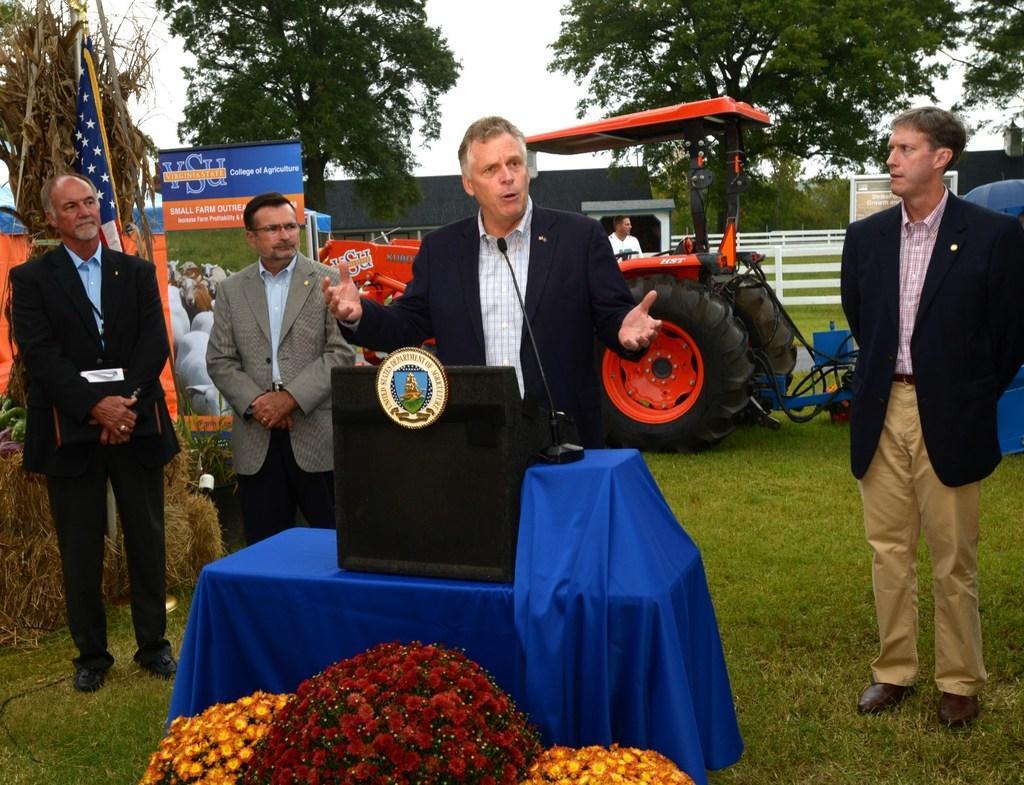Could you give a brief overview of what you see in this image? In this image we can see few persons are standing and a man is standing at the table and there is a microphone and objects on the table. At the bottom we can see flowers. In the background there is a tractor, trees, flag, hoardings and sky. 